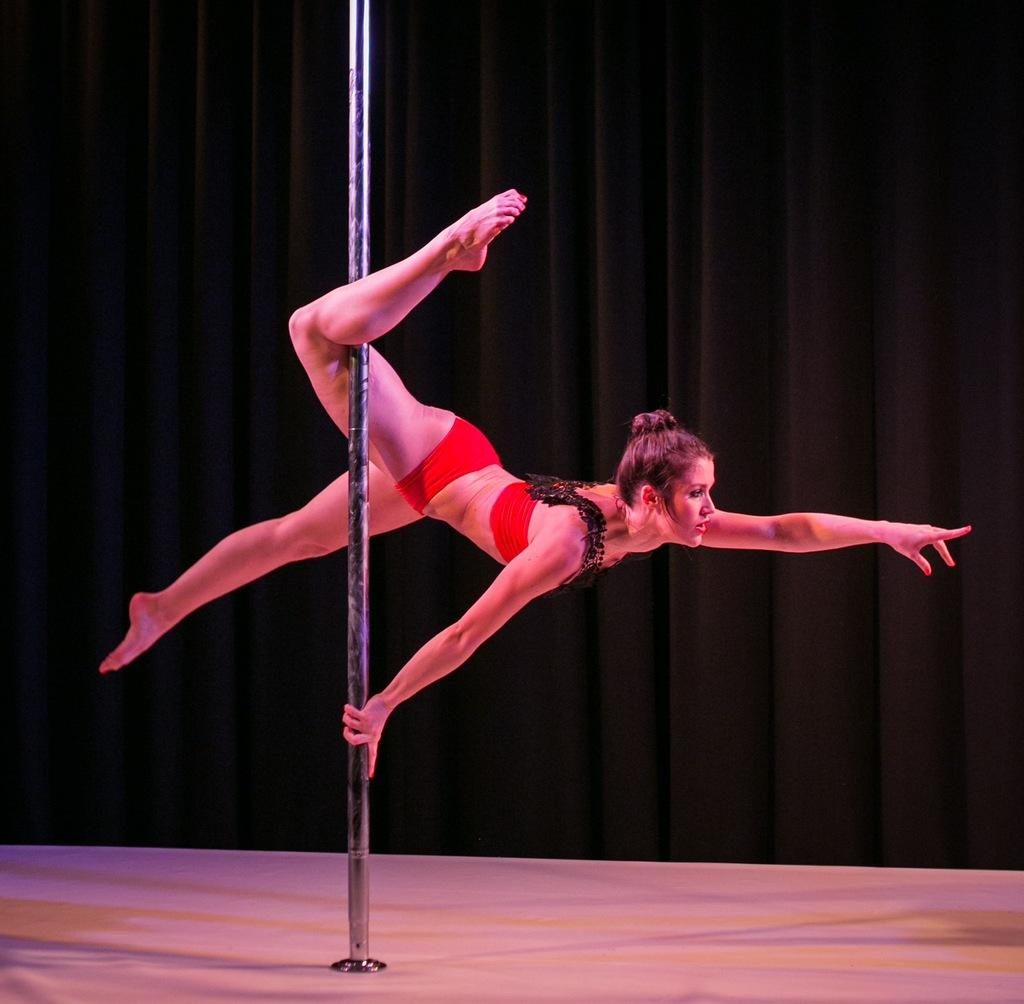Who is the main subject in the image? There is a woman in the image. What is the woman holding in the image? The woman is holding a pole. What color is the surface at the bottom of the image? The surface at the bottom of the image is white. What can be seen in the background of the image? The background of the image includes black curtains. How many baseballs can be seen on the scale in the image? There are no baseballs or scales present in the image. What type of finger is visible on the woman's hand in the image? There is no finger visible on the woman's hand in the image; only her hand holding the pole can be seen. 